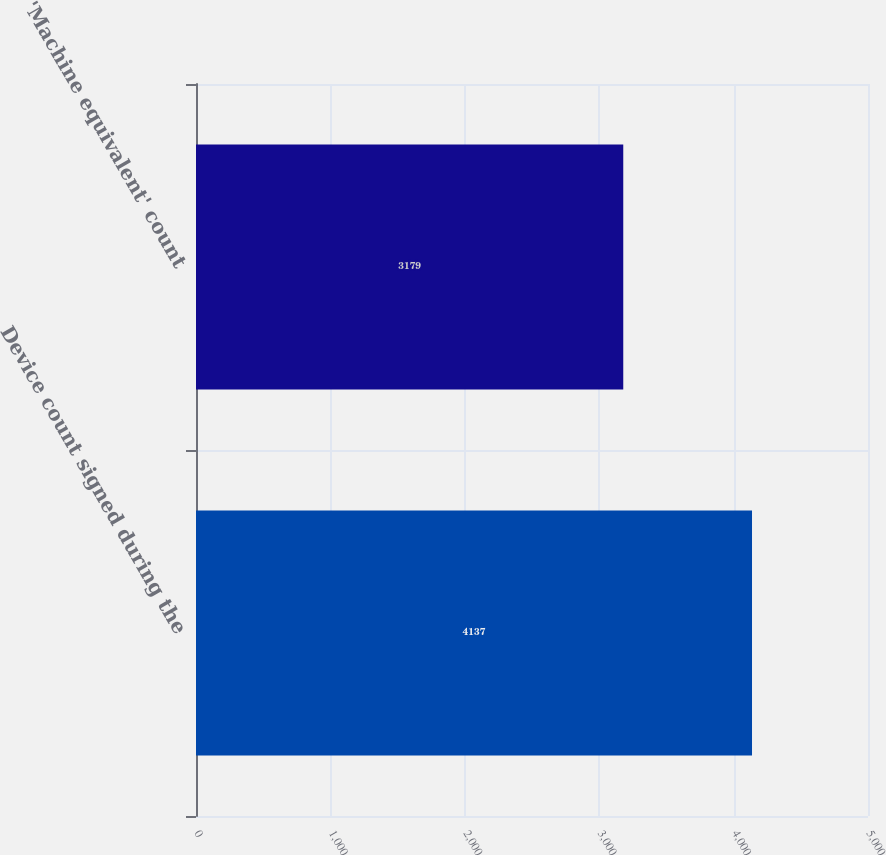<chart> <loc_0><loc_0><loc_500><loc_500><bar_chart><fcel>Device count signed during the<fcel>'Machine equivalent' count<nl><fcel>4137<fcel>3179<nl></chart> 